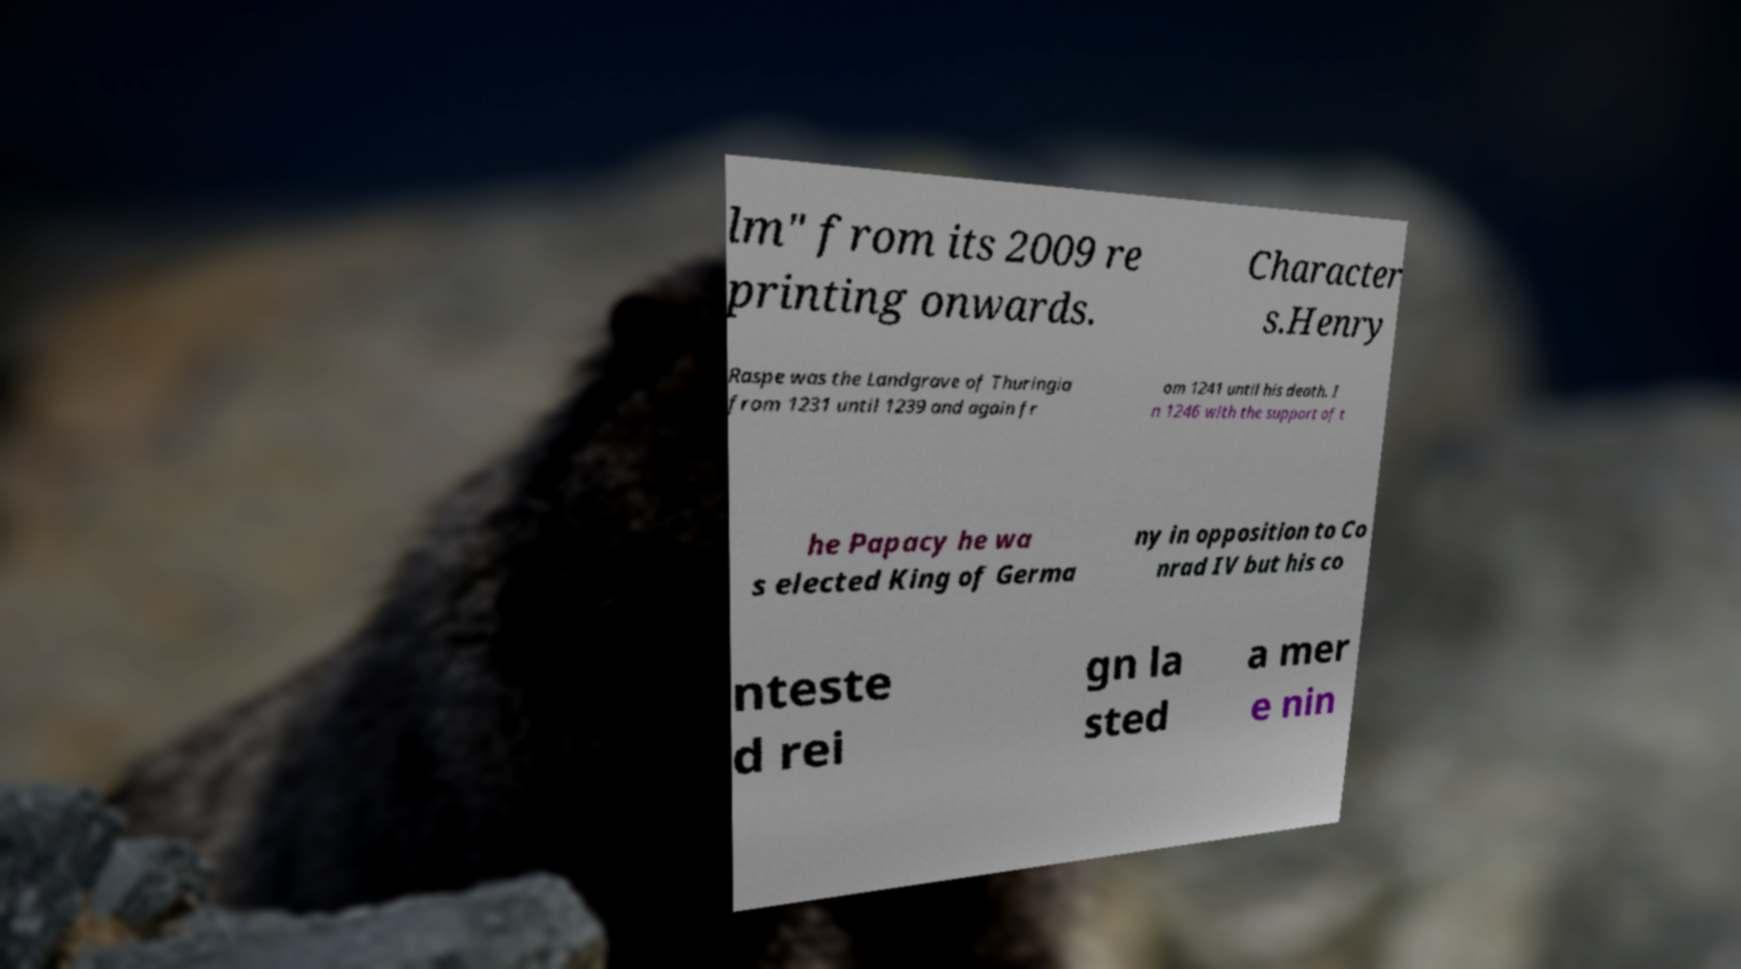I need the written content from this picture converted into text. Can you do that? lm" from its 2009 re printing onwards. Character s.Henry Raspe was the Landgrave of Thuringia from 1231 until 1239 and again fr om 1241 until his death. I n 1246 with the support of t he Papacy he wa s elected King of Germa ny in opposition to Co nrad IV but his co nteste d rei gn la sted a mer e nin 